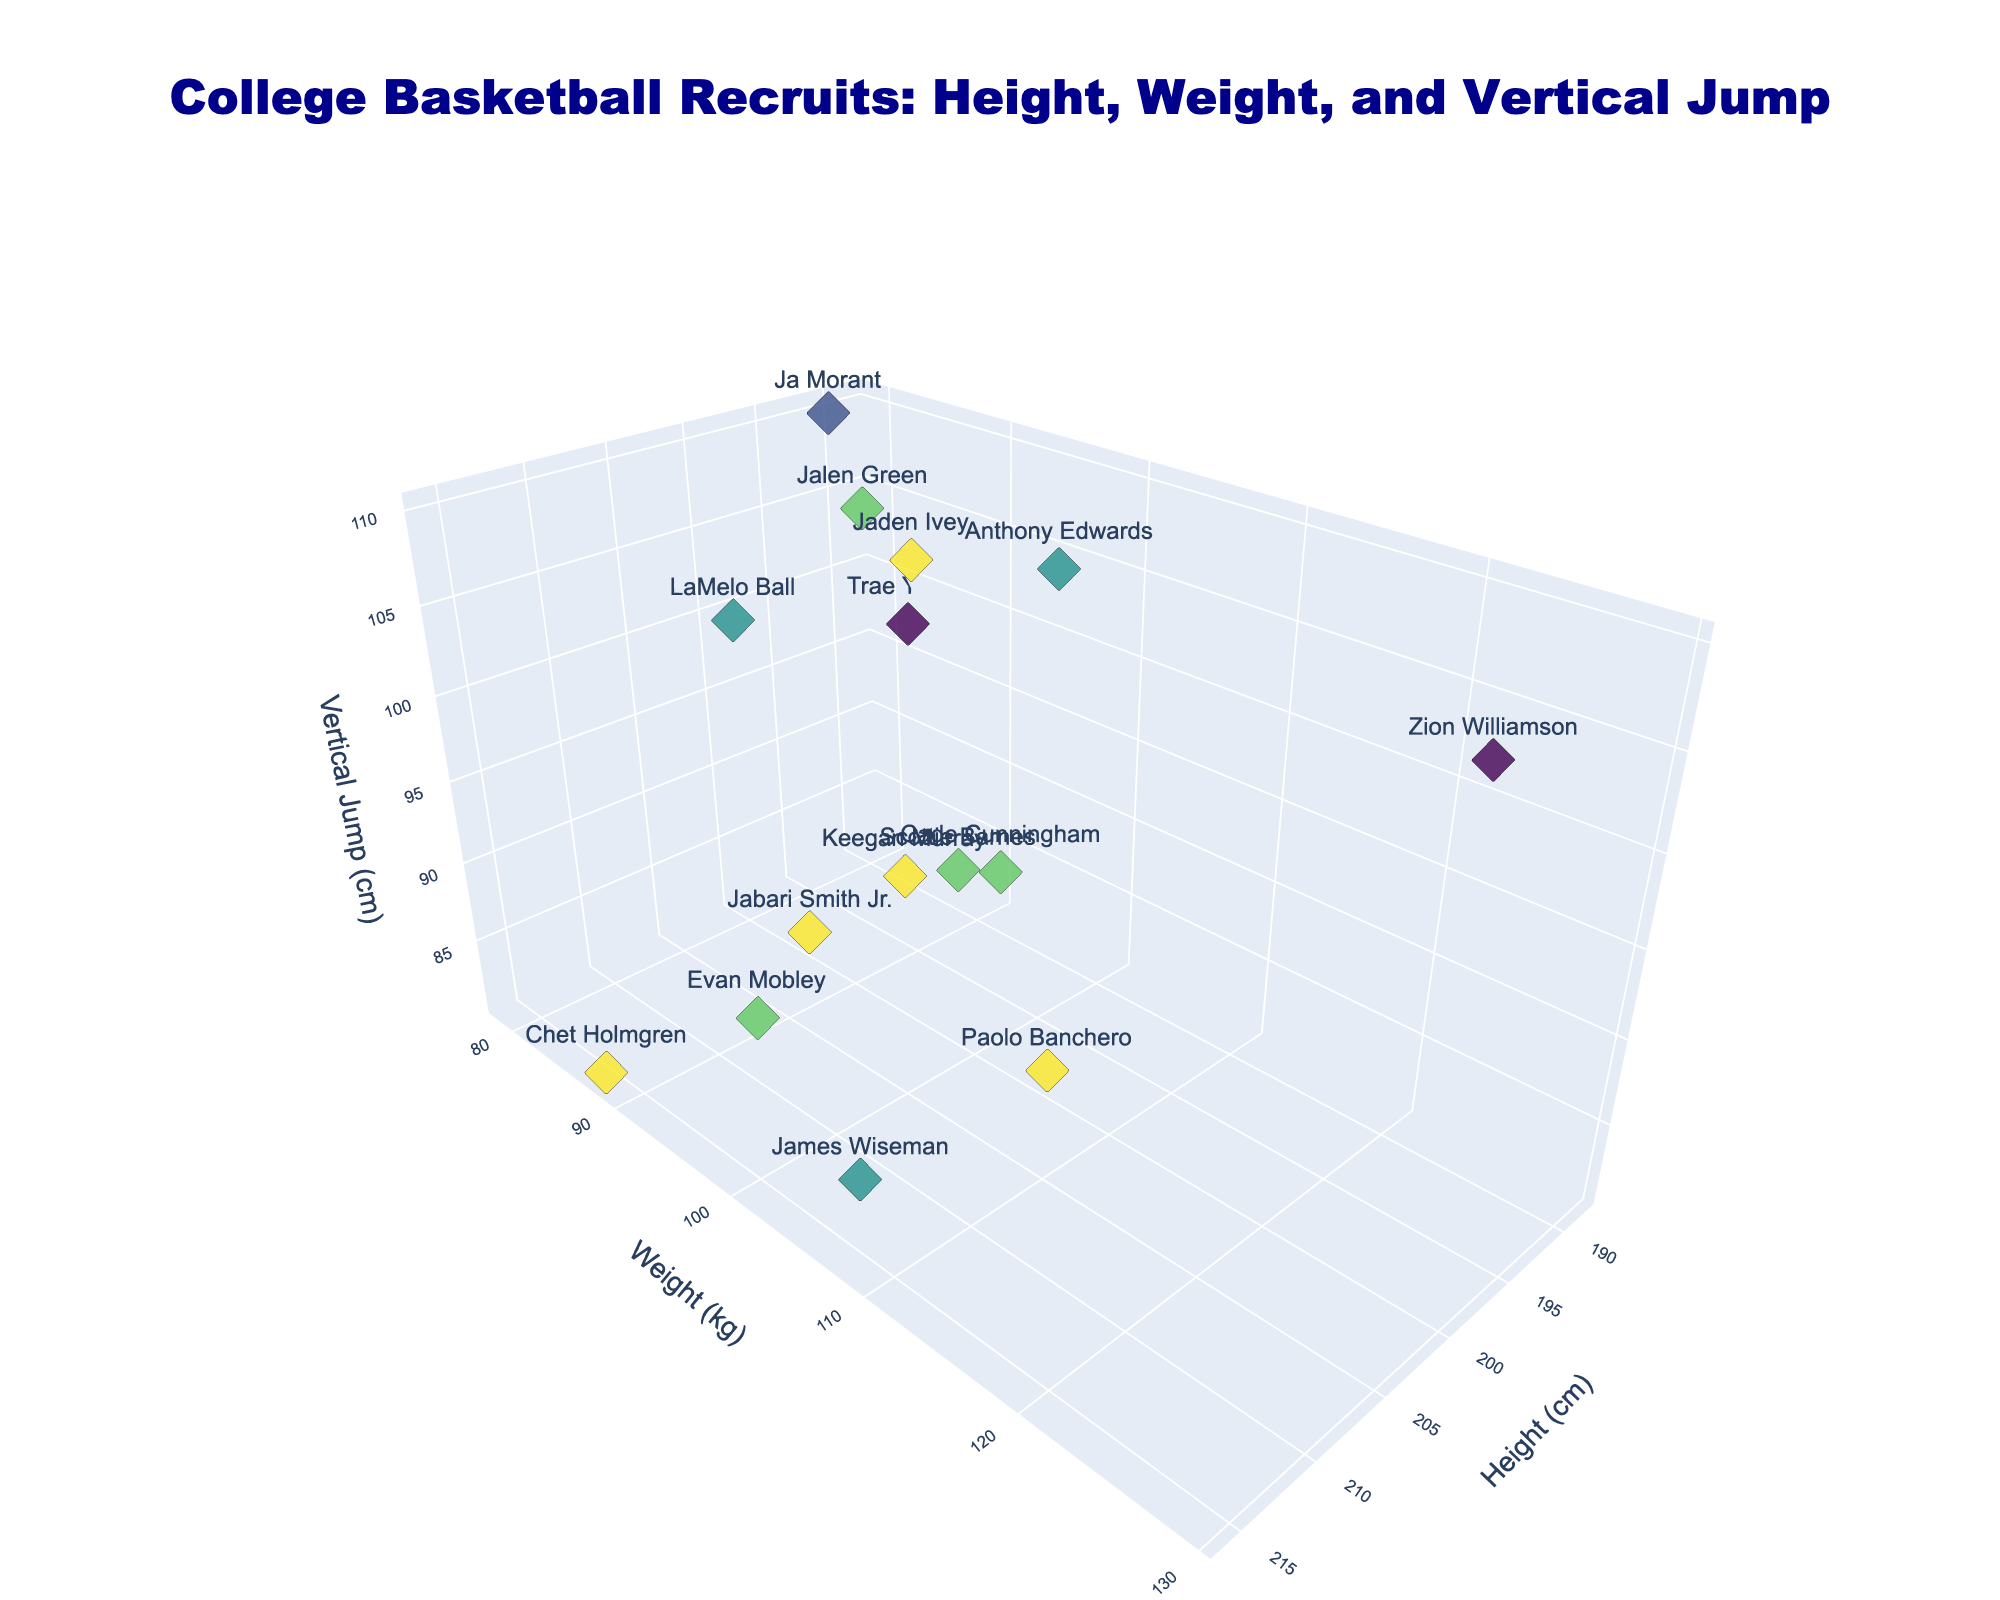What's the title of the plot? The title is always located at the top of the figure and provides the main topic or focus of the chart. The title in this plot is "College Basketball Recruits: Height, Weight, and Vertical Jump".
Answer: College Basketball Recruits: Height, Weight, and Vertical Jump How many data points are represented in the plot? To determine the number of data points, we count the markers shown in the plot. Each recruit is represented by one marker.
Answer: 15 What's the axis title for the x-axis? The x-axis title is displayed along the horizontal axis in the plot, indicating what data is being measured. In this plot, the x-axis represents "Height (cm)".
Answer: Height (cm) Which player has the highest vertical jump? By examining the z-axis (Vertical Jump), identify the data point that is positioned the highest. Ja Morant, with a vertical jump of 110 cm, is at the highest point.
Answer: Ja Morant Which player weighs the most? By looking at the y-axis (Weight), identify the data point that is positioned the furthest to the right. Zion Williamson weighs the most at 129 kg.
Answer: Zion Williamson Which year has the most recruits on the plot? Visual inspection of the color coded data points reveals the year with the most occurrences. 2022 has the most recruits.
Answer: 2022 What is the average height of the recruits shown? Find heights of all 15 recruits: (201+191+188+198+196+216+201+203+213+193+208+211+216+193+203) cm. Sum these heights and divide by the number of recruits: (3032 / 15) cm.
Answer: 202 cm Which player has the lowest vertical jump, and what is it? By inspecting the z-axis for the lowest point, Chet Holmgren has the lowest vertical jump at 81 cm.
Answer: Chet Holmgren, 81 cm Are there any players with the same height but different weights? By observing the x-axis for repeated height values and then comparing the corresponding y-values, LaMelo Ball and Zion Williamson both are 201 cm but have different weights? 82 kg and 129 kg, respectively.
Answer: Yes, LaMelo Ball and Zion Williamson 